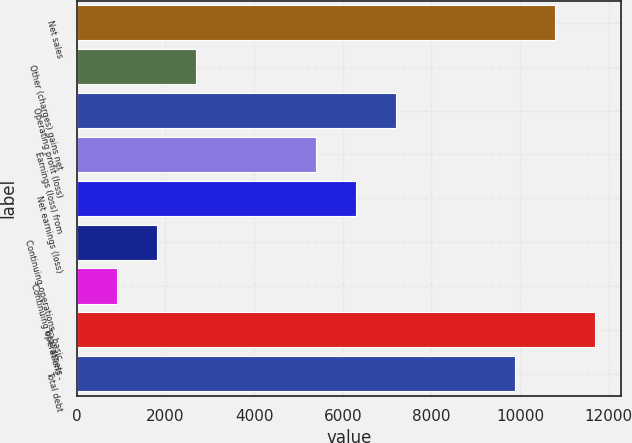Convert chart. <chart><loc_0><loc_0><loc_500><loc_500><bar_chart><fcel>Net sales<fcel>Other (charges) gains net<fcel>Operating profit (loss)<fcel>Earnings (loss) from<fcel>Net earnings (loss)<fcel>Continuing operations - basic<fcel>Continuing operations -<fcel>Total assets<fcel>Total debt<nl><fcel>10792.7<fcel>2698.58<fcel>7195.33<fcel>5396.63<fcel>6295.98<fcel>1799.23<fcel>899.88<fcel>11692.1<fcel>9893.38<nl></chart> 